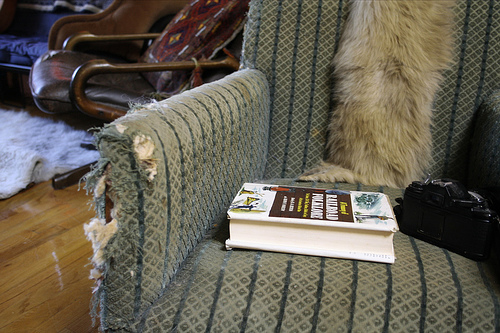<image>
Is there a book on the chair? Yes. Looking at the image, I can see the book is positioned on top of the chair, with the chair providing support. Where is the book in relation to the floor? Is it on the floor? No. The book is not positioned on the floor. They may be near each other, but the book is not supported by or resting on top of the floor. Is the book in front of the fur? Yes. The book is positioned in front of the fur, appearing closer to the camera viewpoint. 